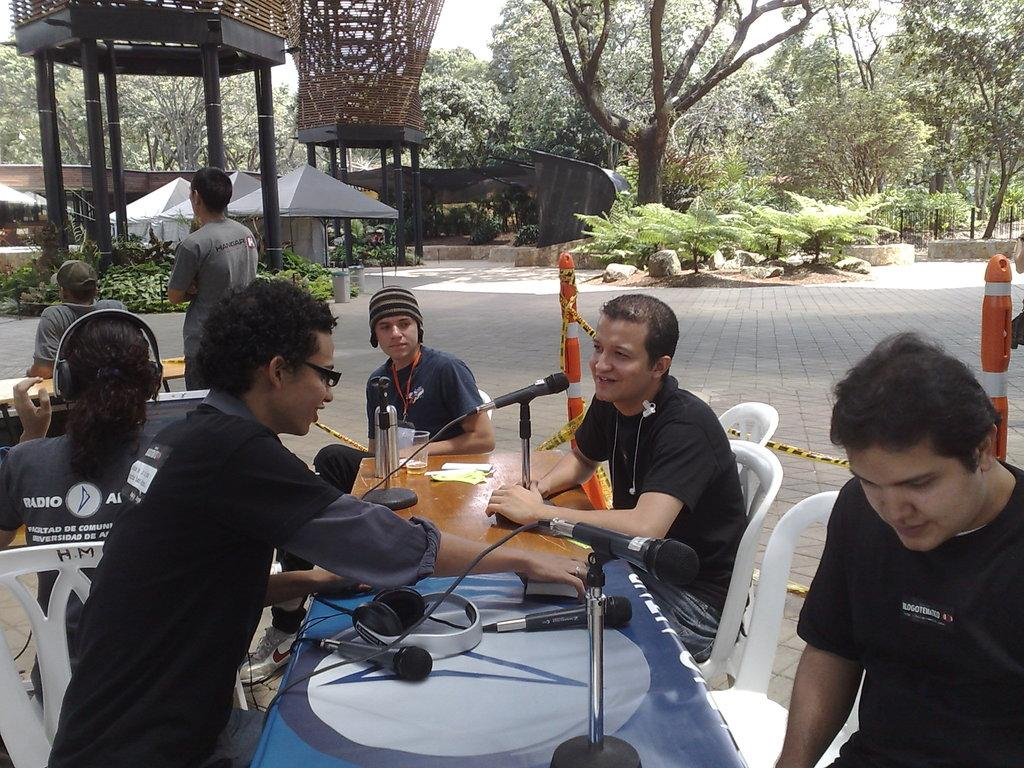What are the people in the image doing? The people in the image are sitting on chairs. What object can be seen on the table in the image? There is a mic on a table in the image. What can be seen in the background of the image? There are trees visible in the background of the image. What is the smell of the baby in the image? There is no baby present in the image, so it is not possible to determine the smell. 